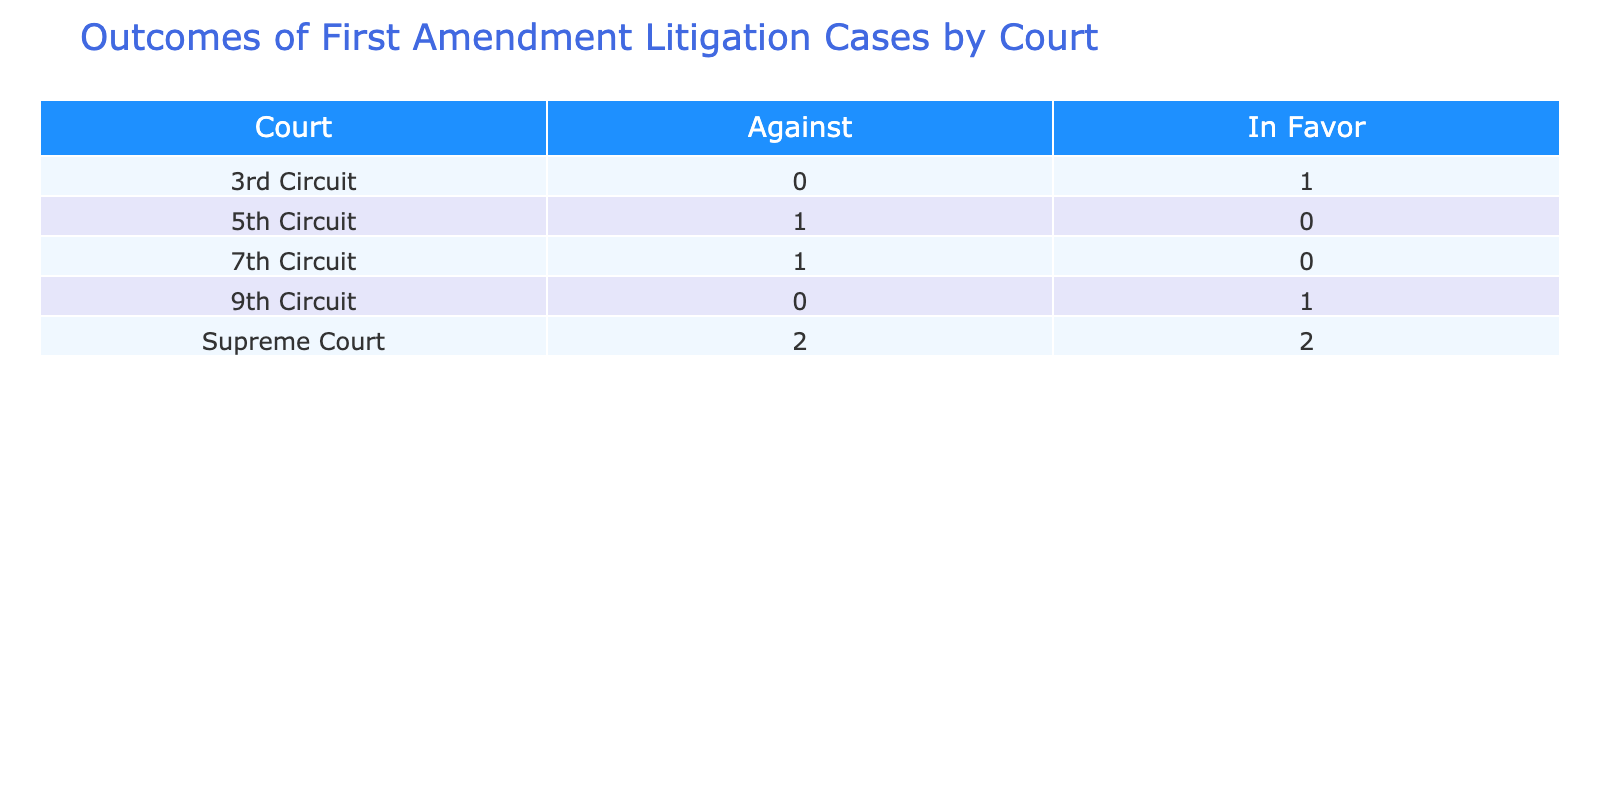What is the total number of cases listed for the Supreme Court? There are four cases listed under the Supreme Court. We can verify by counting the rows that contain "Supreme Court" in the Court column.
Answer: 4 How many cases resulted in a decision against student expression across all courts? There are three cases that resulted in a decision against student expression. These can be found by counting the occurrences of "Against" in the Outcome column for all courts.
Answer: 3 Which court had the most cases listed? The Supreme Court had the most cases listed, with a total of four. We compare the number of cases for each court and find that the Supreme Court has more entries than any other court.
Answer: Supreme Court Did any court rule in favor of artistic expression? Yes, the 9th Circuit ruled in favor of artistic expression in the case of Harvey v. Smith in 2018. We check the "Outcome" column for "In Favor" and look for "Artistic Expression" under the Student Expression Type column.
Answer: Yes What is the ratio of cases in favor of student expression to cases against it for the 3rd Circuit? The 3rd Circuit has one case listed that was in favor of student expression and none against it. The ratio of favorable cases to unfavorable cases is therefore 1 to 0, but this can also be represented as it being entirely in favor since there are no cases against.
Answer: 1:0 How many cases involved lewd speech? There is only one case involving lewd speech, which is the case of Bethel School District No. 403 v. Fraser in 1986. We can identify this by looking for "Lewd Speech" under the Student Expression Type column and counting its occurrences.
Answer: 1 Which court has the highest number of cases with an "In Favor" outcome? The Supreme Court holds the highest number of cases with an "In Favor" outcome, totaling two cases: Tinker v. Des Moines Independent Community School District and Nebraska Press Association v. Stuart. We examine how many "In Favor" outcomes each court has and confirm the count.
Answer: Supreme Court For cases decided in favor of student journalism, which court ruled? The 3rd Circuit ruled in favor of student journalism in the case of Student Press Law Center v. McCleary High School in 2020. We can identify this by looking for "In Favor" in the Outcome column that aligns with "Student Journalism" in the Student Expression Type column.
Answer: 3rd Circuit 